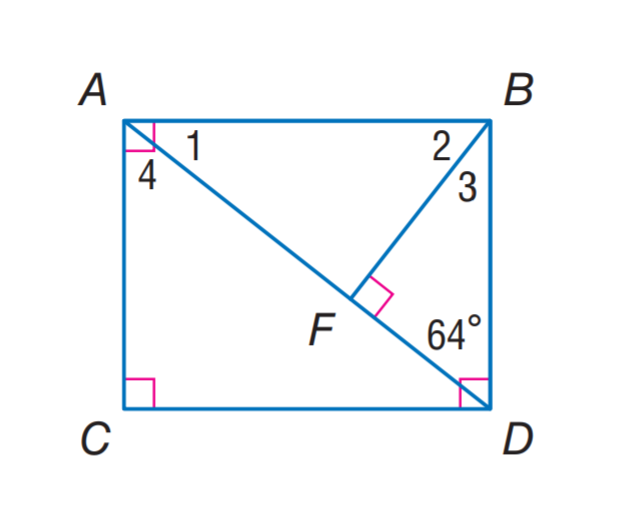Question: Find m \angle 4.
Choices:
A. 26
B. 32
C. 64
D. 78
Answer with the letter. Answer: C Question: Find m \angle 1.
Choices:
A. 26
B. 32
C. 58
D. 64
Answer with the letter. Answer: A 